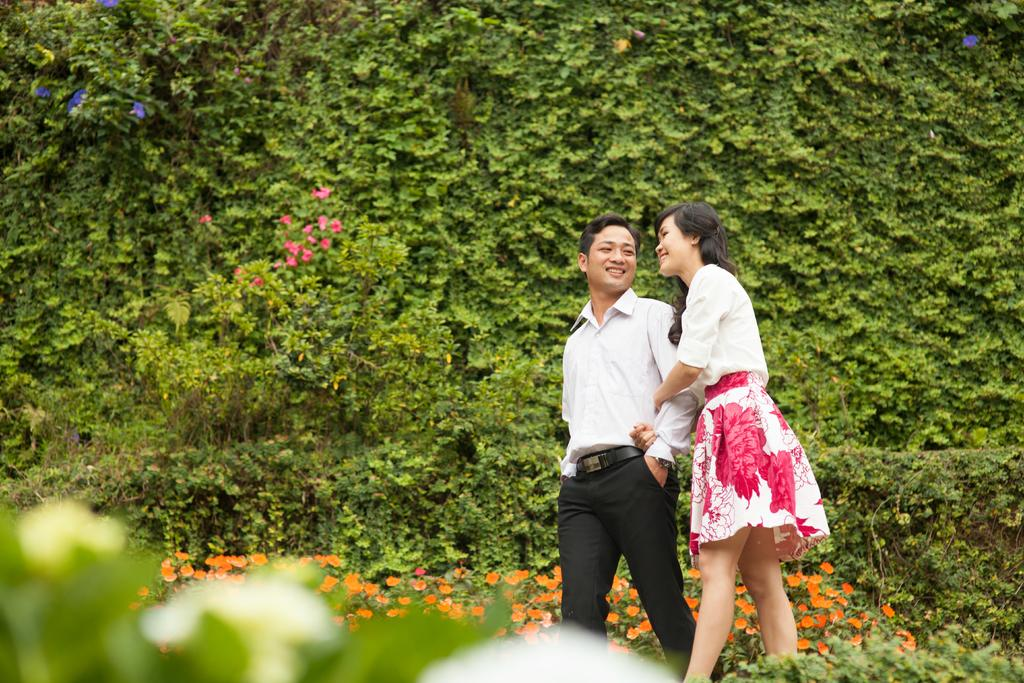Who can be seen in the image? There is a man and a woman in the image. What are the man and woman doing in the image? The man and woman are walking. What type of plants are at the bottom of the image? There are small plants with orange flowers at the bottom of the image. What can be seen in the background of the image? There are many plants in green color in the background of the image. Can you see any icicles hanging from the plants in the image? No, there are no icicles present in the image. How are the waves affecting the plants in the image? There are no waves present in the image, as it features a man and woman walking and plants in a natural setting. 